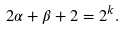<formula> <loc_0><loc_0><loc_500><loc_500>2 \alpha + \beta + 2 = 2 ^ { k } .</formula> 